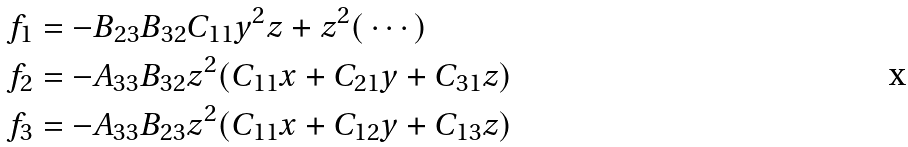<formula> <loc_0><loc_0><loc_500><loc_500>f _ { 1 } & = - B _ { 2 3 } B _ { 3 2 } C _ { 1 1 } y ^ { 2 } z + z ^ { 2 } ( \, \cdots ) \\ f _ { 2 } & = - A _ { 3 3 } B _ { 3 2 } z ^ { 2 } ( C _ { 1 1 } x + C _ { 2 1 } y + C _ { 3 1 } z ) \\ f _ { 3 } & = - A _ { 3 3 } B _ { 2 3 } z ^ { 2 } ( C _ { 1 1 } x + C _ { 1 2 } y + C _ { 1 3 } z )</formula> 